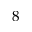<formula> <loc_0><loc_0><loc_500><loc_500>8</formula> 